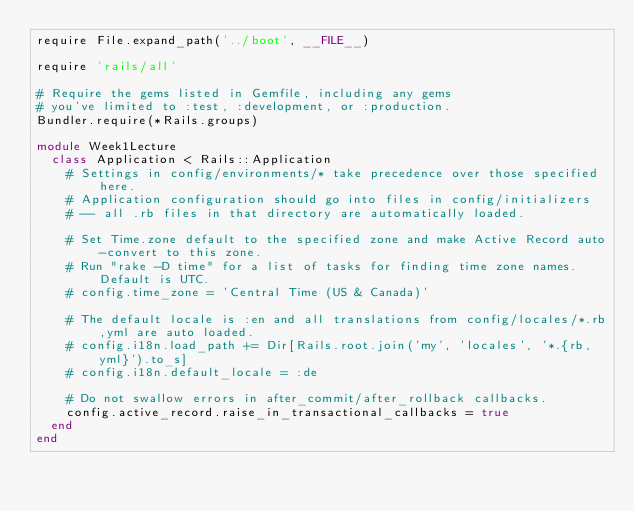Convert code to text. <code><loc_0><loc_0><loc_500><loc_500><_Ruby_>require File.expand_path('../boot', __FILE__)

require 'rails/all'

# Require the gems listed in Gemfile, including any gems
# you've limited to :test, :development, or :production.
Bundler.require(*Rails.groups)

module Week1Lecture
  class Application < Rails::Application
    # Settings in config/environments/* take precedence over those specified here.
    # Application configuration should go into files in config/initializers
    # -- all .rb files in that directory are automatically loaded.

    # Set Time.zone default to the specified zone and make Active Record auto-convert to this zone.
    # Run "rake -D time" for a list of tasks for finding time zone names. Default is UTC.
    # config.time_zone = 'Central Time (US & Canada)'

    # The default locale is :en and all translations from config/locales/*.rb,yml are auto loaded.
    # config.i18n.load_path += Dir[Rails.root.join('my', 'locales', '*.{rb,yml}').to_s]
    # config.i18n.default_locale = :de

    # Do not swallow errors in after_commit/after_rollback callbacks.
    config.active_record.raise_in_transactional_callbacks = true
  end
end
</code> 